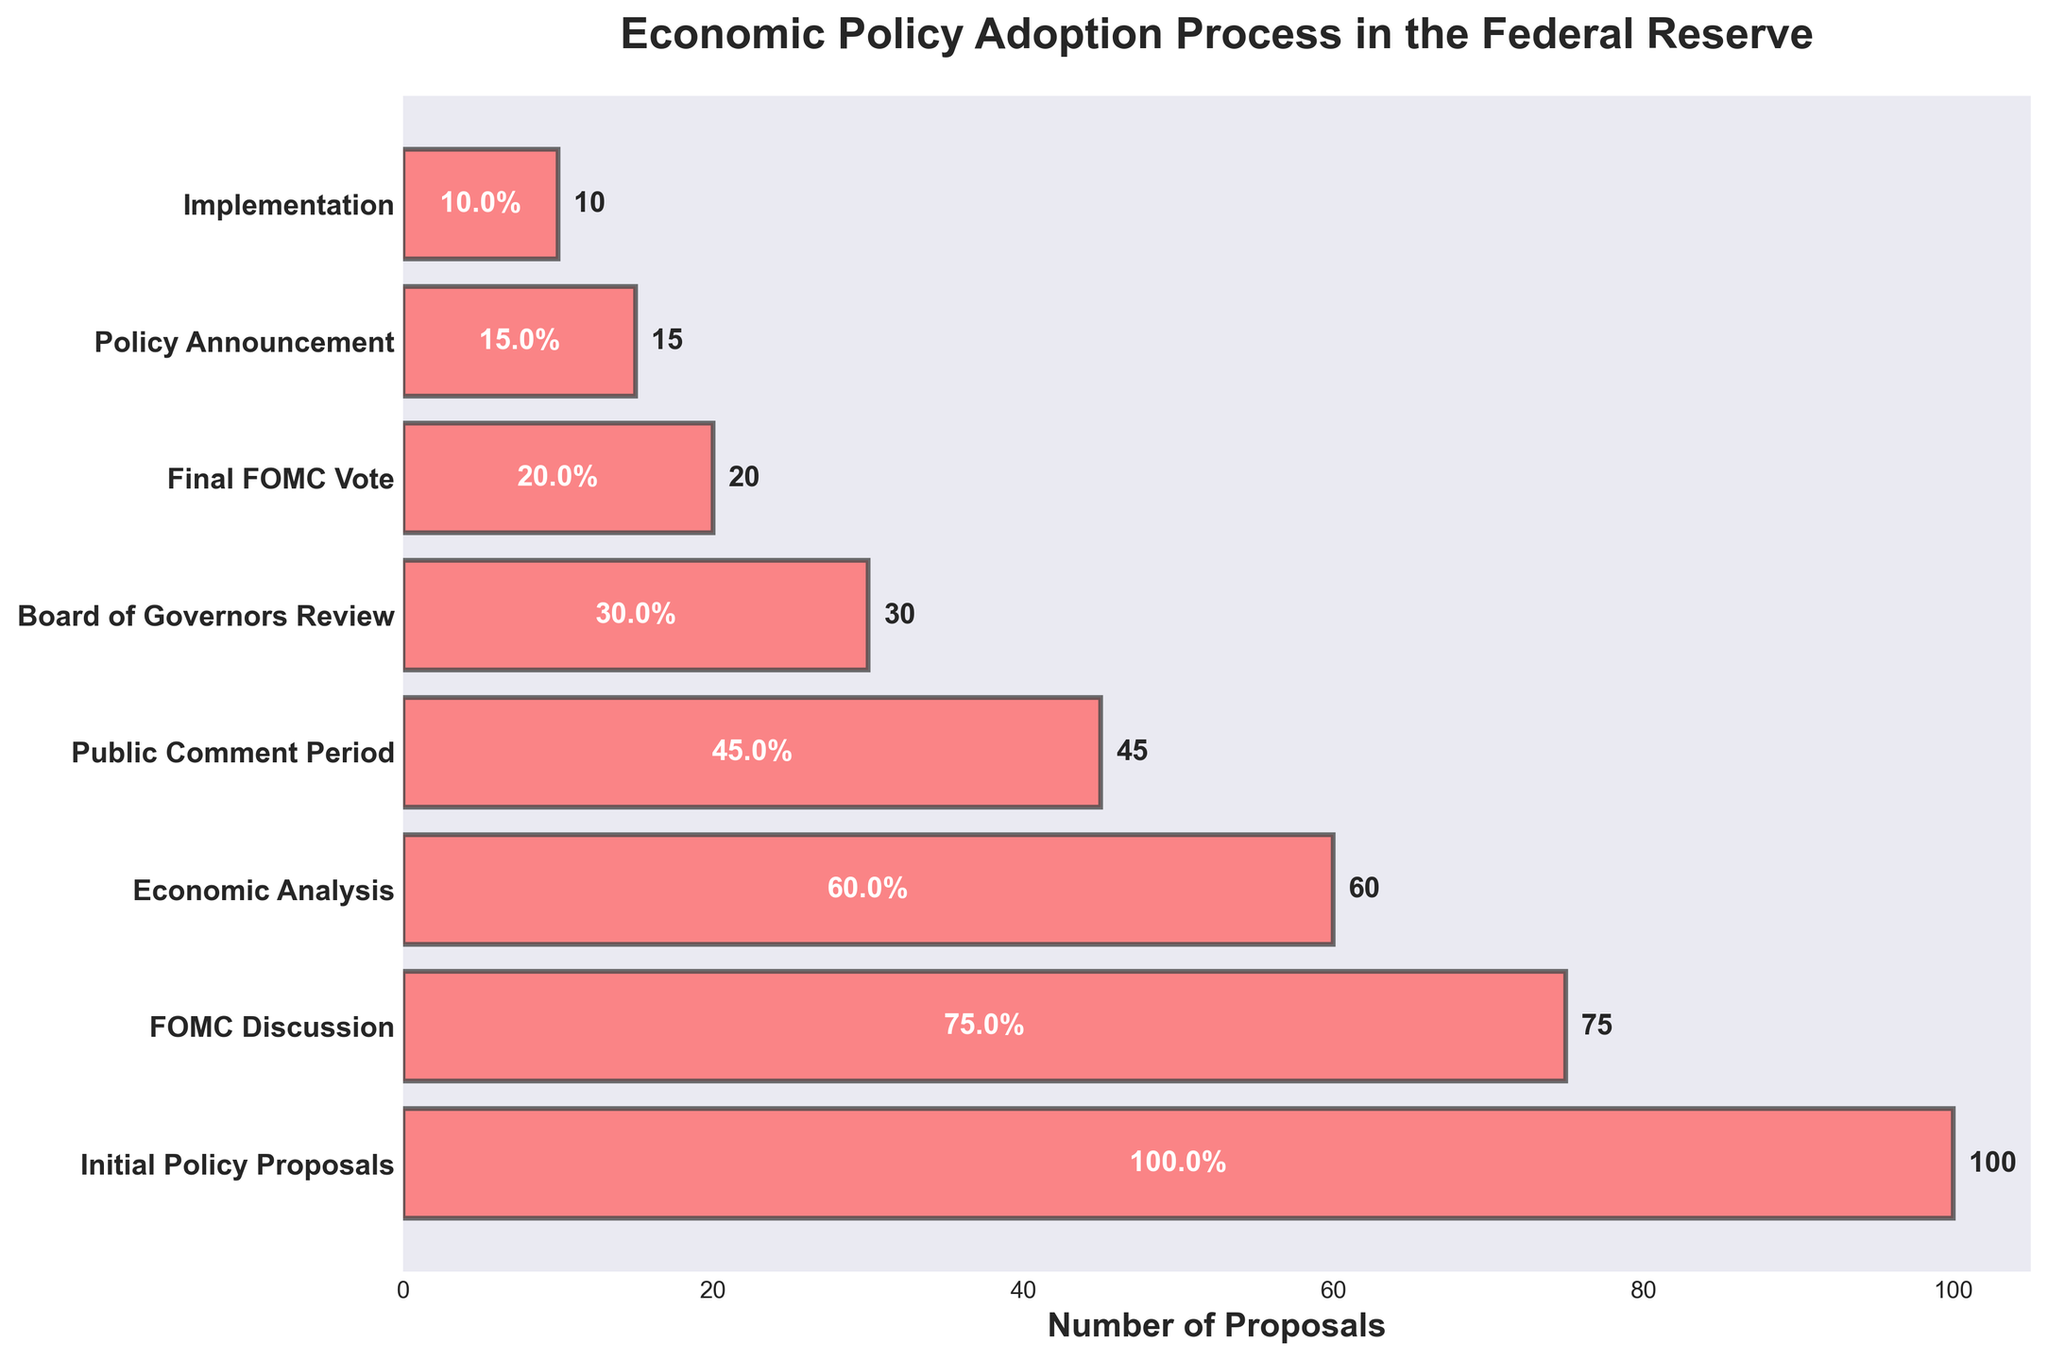What's the title of the figure? The title appears at the top of the figure and it reads "Economic Policy Adoption Process in the Federal Reserve."
Answer: Economic Policy Adoption Process in the Federal Reserve How many proposals move from Initial Policy Proposals to FOMC Discussion? Initial Policy Proposals stage has 100 proposals, and FOMC Discussion stage has 75 proposals. So, 100 - 75 = 25 proposals do not move forward, meaning 75 proposals move to FOMC Discussion.
Answer: 75 By what percentage do the proposals decrease from Initial Policy Proposals to Public Comment Period? The proposals decrease from 100 at Initial Policy Proposals to 45 at Public Comment Period. The percentage decrease is calculated as [(100 - 45) / 100] * 100 = 55%.
Answer: 55% Which stage sees a reduction of 30 proposals compared to the previous one? The proposals drop from 75 to 45 between FOMC Discussion and Public Comment Period, which is a 30 proposal decrease.
Answer: Public Comment Period How many proposals reach the Implementation stage? According to the chart, the Implementation stage has 10 proposals.
Answer: 10 What is the largest single-stage drop in the number of proposals, and between which stages does it occur? The largest single-stage drop can be found by inspecting each pair of consecutive stages. The largest drop is from 45 to 30 proposals, a decrease of 15, between Public Comment Period and Board of Governors Review.
Answer: 15 proposals, Public Comment Period to Board of Governors Review What percentage of the initial proposals reach the Final FOMC Vote stage? There are 20 proposals at the Final FOMC Vote stage out of the initial 100. The percentage is calculated as (20 / 100) * 100 = 20%.
Answer: 20% What is the combined number of proposals at the stages: Economic Analysis and Board of Governors Review? Economic Analysis has 60 proposals and Board of Governors Review has 30 proposals. Combined, they have 60 + 30 = 90 proposals.
Answer: 90 Compare the number of proposals between Public Comment Period and Policy Announcement stages. Which one has more, and by how much? Public Comment Period has 45 proposals, and Policy Announcement has 15 proposals. Public Comment Period has more by 45 - 15 = 30 proposals.
Answer: Public Comment Period by 30 proposals At which stage is the midway point in terms of the number of stages from Initial Policy Proposals to Implementation and how many proposals are at this stage? There are a total of 8 stages. The midway point is at the 4th stage, which is the Public Comment Period, with 45 proposals.
Answer: Public Comment Period, 45 